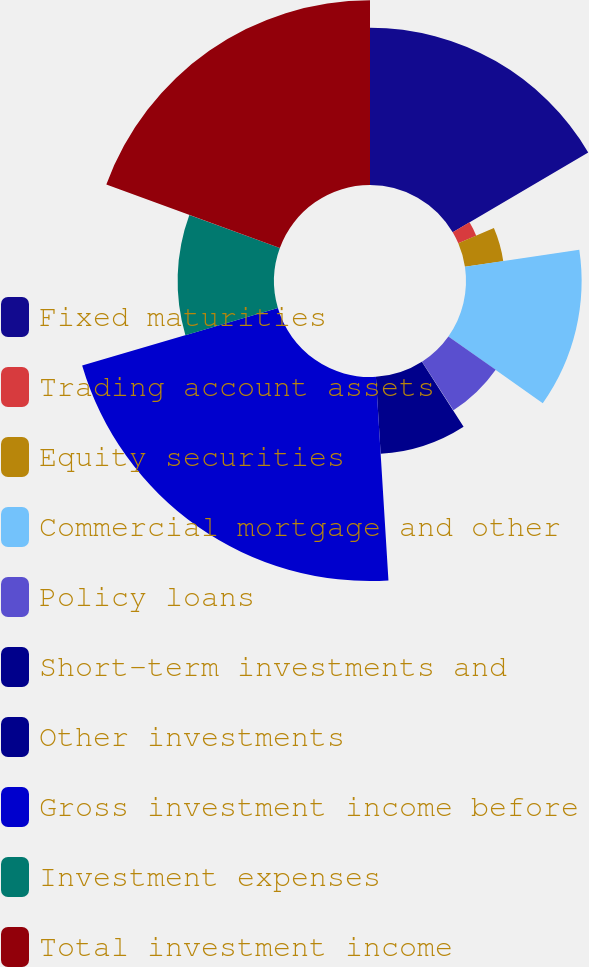Convert chart. <chart><loc_0><loc_0><loc_500><loc_500><pie_chart><fcel>Fixed maturities<fcel>Trading account assets<fcel>Equity securities<fcel>Commercial mortgage and other<fcel>Policy loans<fcel>Short-term investments and<fcel>Other investments<fcel>Gross investment income before<fcel>Investment expenses<fcel>Total investment income<nl><fcel>16.53%<fcel>2.05%<fcel>4.07%<fcel>12.15%<fcel>6.09%<fcel>0.03%<fcel>8.11%<fcel>21.44%<fcel>10.13%<fcel>19.42%<nl></chart> 